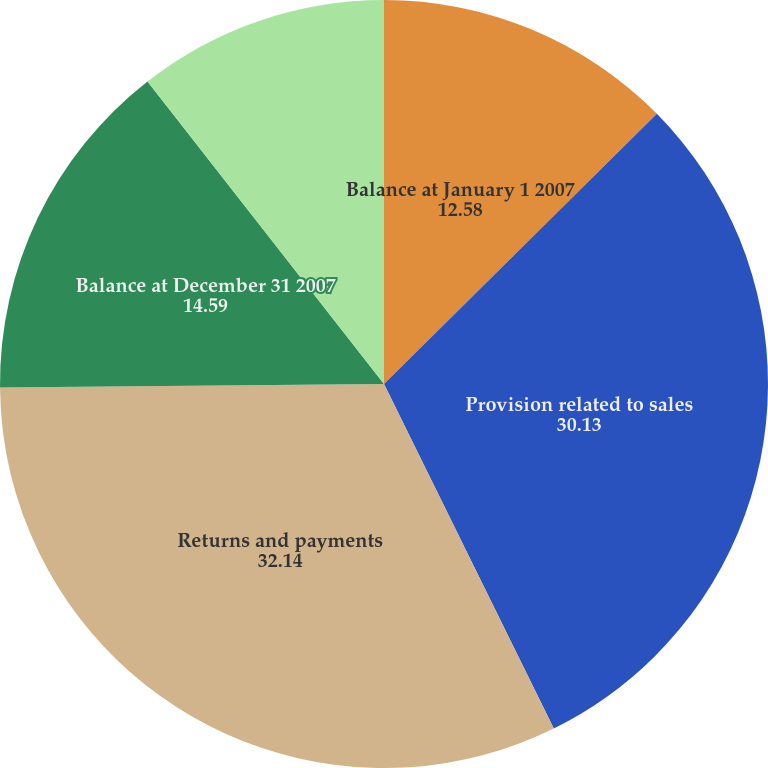Convert chart. <chart><loc_0><loc_0><loc_500><loc_500><pie_chart><fcel>Balance at January 1 2007<fcel>Provision related to sales<fcel>Returns and payments<fcel>Balance at December 31 2007<fcel>Balance at December 31 2008<nl><fcel>12.58%<fcel>30.13%<fcel>32.14%<fcel>14.59%<fcel>10.56%<nl></chart> 